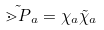<formula> <loc_0><loc_0><loc_500><loc_500>\tilde { \mathbb { m } { P } } _ { a } = \chi _ { a } \tilde { \chi } _ { a }</formula> 